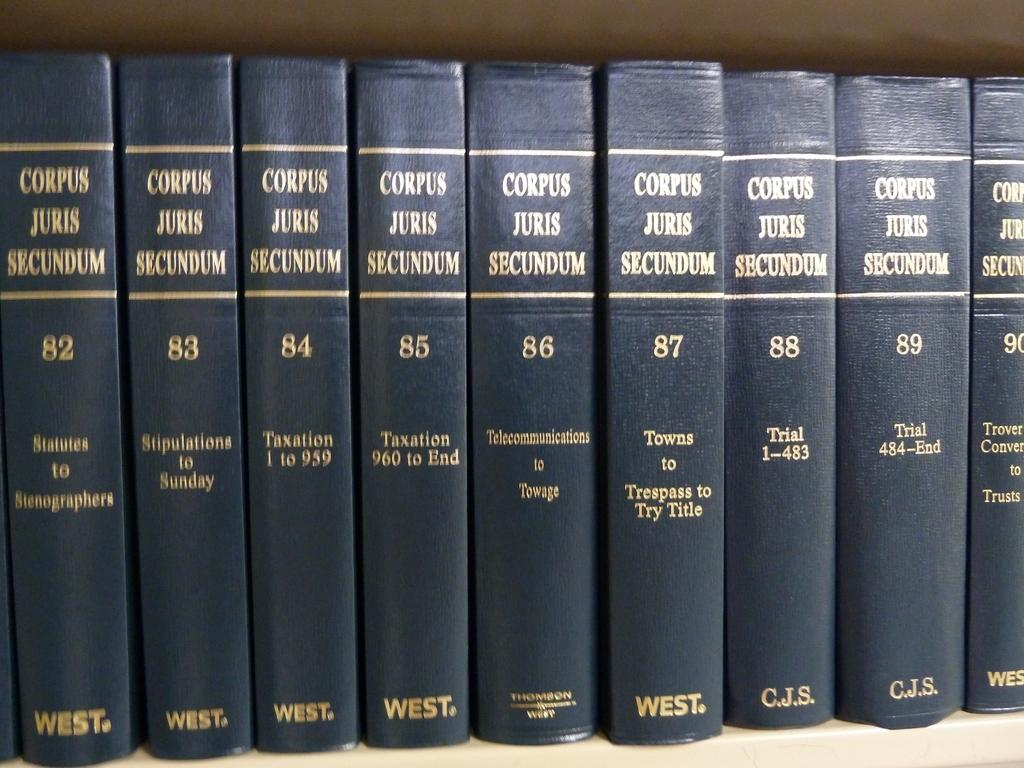<image>
Create a compact narrative representing the image presented. A collection of books called "Corpus Juris Sucundum" volumes 82 through 90 sit in a row. 